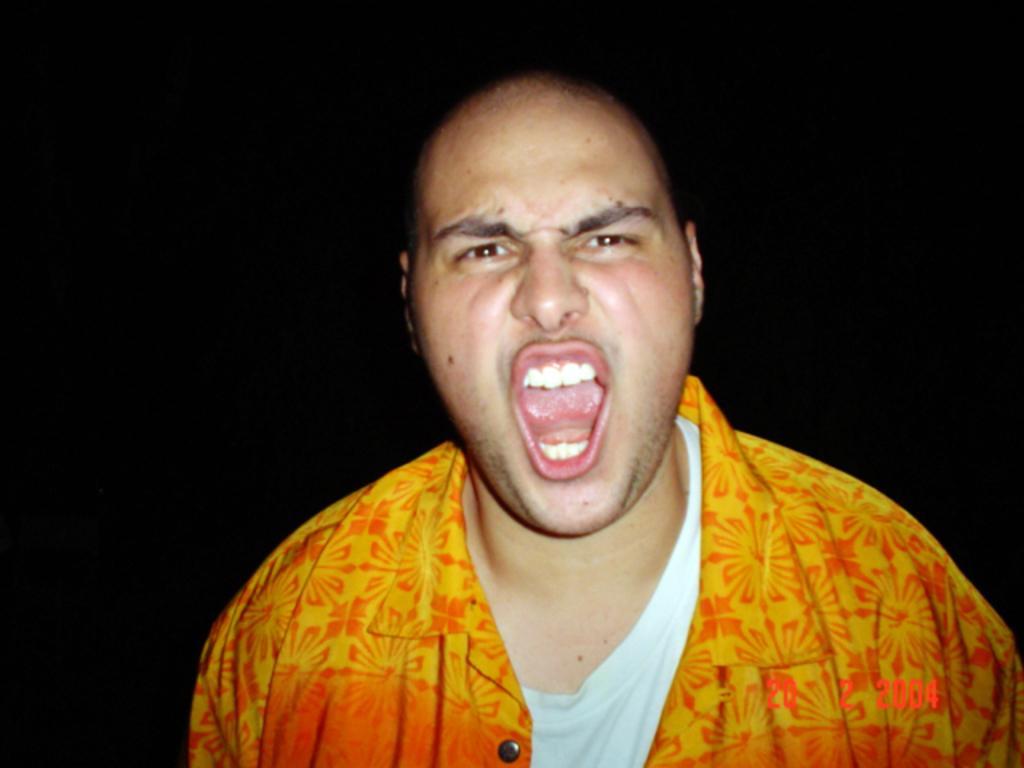How would you summarize this image in a sentence or two? In the center of the image we can see a man and the background is in black color. In the bottom right corner we can see the date. 